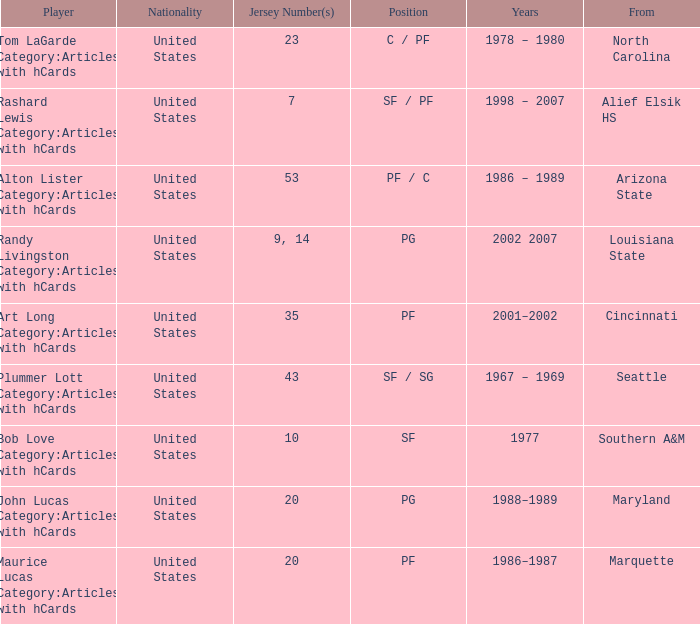Alton Lister Category:Articles with hCards has what as the listed years? 1986 – 1989. 